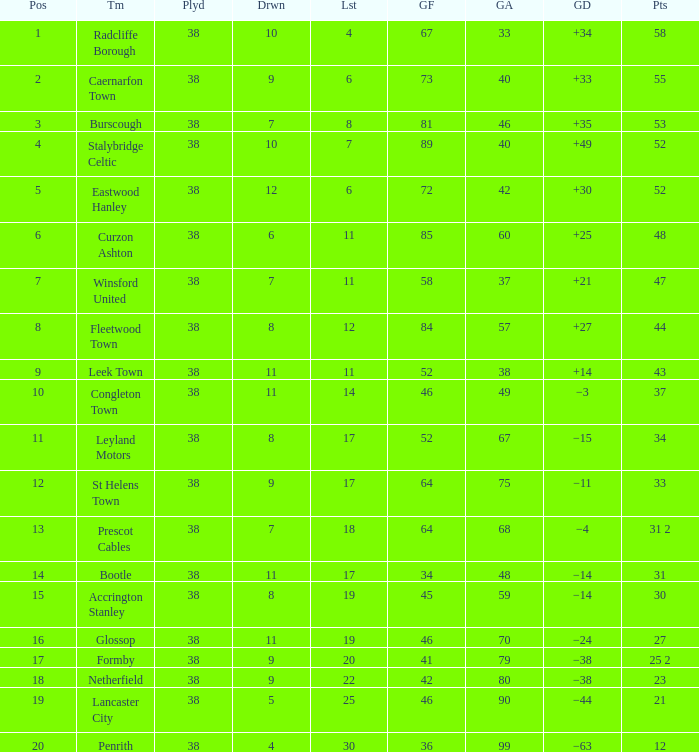WHAT GOALS AGAINST HAD A GOAL FOR OF 46, AND PLAYED LESS THAN 38? None. 